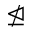<formula> <loc_0><loc_0><loc_500><loc_500>\ntrianglelefteq</formula> 